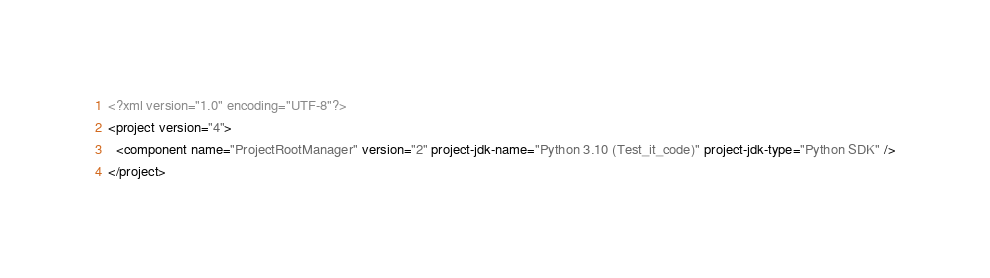Convert code to text. <code><loc_0><loc_0><loc_500><loc_500><_XML_><?xml version="1.0" encoding="UTF-8"?>
<project version="4">
  <component name="ProjectRootManager" version="2" project-jdk-name="Python 3.10 (Test_it_code)" project-jdk-type="Python SDK" />
</project></code> 